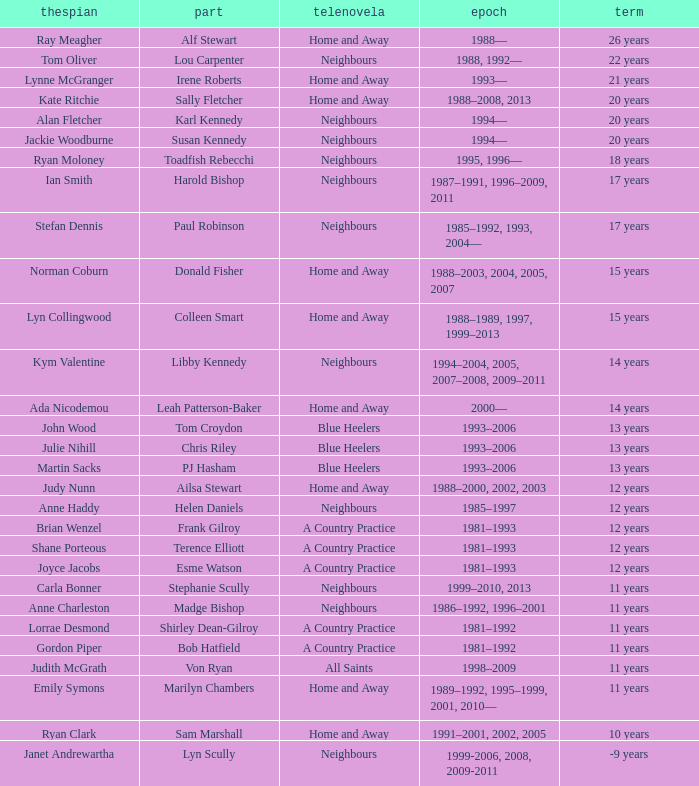Which character was played by the same actor for a span of 12 years on the show neighbours? Helen Daniels. 